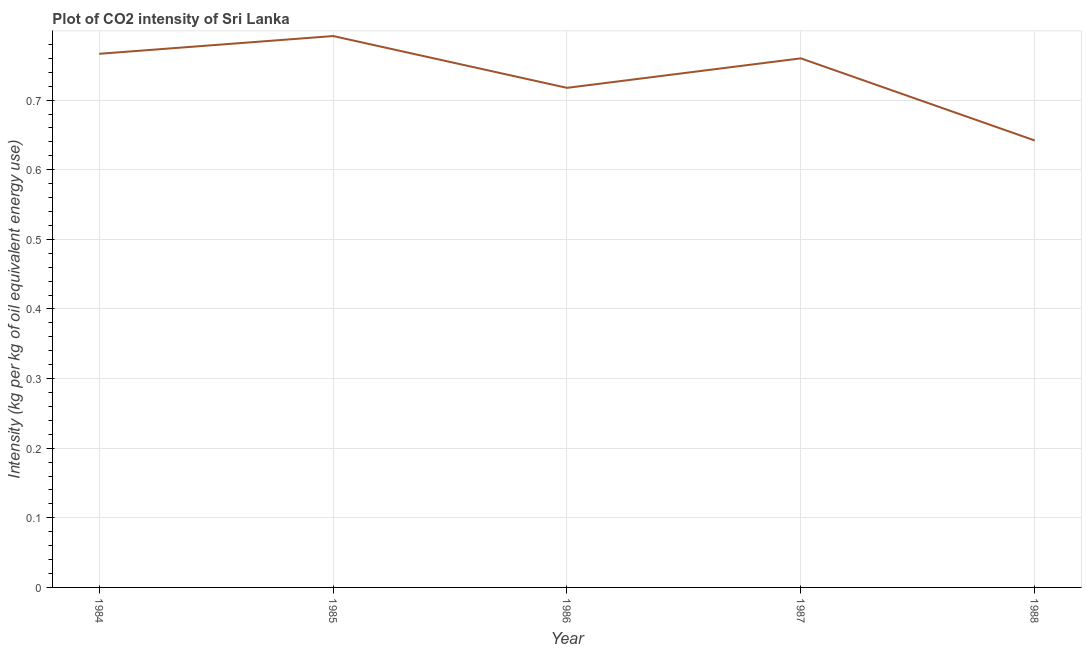What is the co2 intensity in 1988?
Your answer should be compact. 0.64. Across all years, what is the maximum co2 intensity?
Make the answer very short. 0.79. Across all years, what is the minimum co2 intensity?
Your answer should be very brief. 0.64. In which year was the co2 intensity maximum?
Offer a very short reply. 1985. What is the sum of the co2 intensity?
Offer a terse response. 3.68. What is the difference between the co2 intensity in 1985 and 1986?
Your answer should be compact. 0.07. What is the average co2 intensity per year?
Provide a succinct answer. 0.74. What is the median co2 intensity?
Make the answer very short. 0.76. In how many years, is the co2 intensity greater than 0.30000000000000004 kg?
Keep it short and to the point. 5. Do a majority of the years between 1986 and 1985 (inclusive) have co2 intensity greater than 0.6600000000000001 kg?
Ensure brevity in your answer.  No. What is the ratio of the co2 intensity in 1985 to that in 1988?
Offer a terse response. 1.23. Is the co2 intensity in 1984 less than that in 1988?
Your answer should be very brief. No. What is the difference between the highest and the second highest co2 intensity?
Your response must be concise. 0.03. Is the sum of the co2 intensity in 1986 and 1987 greater than the maximum co2 intensity across all years?
Offer a very short reply. Yes. What is the difference between the highest and the lowest co2 intensity?
Offer a terse response. 0.15. Does the co2 intensity monotonically increase over the years?
Your response must be concise. No. How many lines are there?
Provide a succinct answer. 1. What is the difference between two consecutive major ticks on the Y-axis?
Your answer should be compact. 0.1. Are the values on the major ticks of Y-axis written in scientific E-notation?
Your answer should be compact. No. What is the title of the graph?
Make the answer very short. Plot of CO2 intensity of Sri Lanka. What is the label or title of the X-axis?
Make the answer very short. Year. What is the label or title of the Y-axis?
Provide a short and direct response. Intensity (kg per kg of oil equivalent energy use). What is the Intensity (kg per kg of oil equivalent energy use) in 1984?
Your answer should be very brief. 0.77. What is the Intensity (kg per kg of oil equivalent energy use) in 1985?
Provide a short and direct response. 0.79. What is the Intensity (kg per kg of oil equivalent energy use) in 1986?
Your answer should be compact. 0.72. What is the Intensity (kg per kg of oil equivalent energy use) of 1987?
Provide a short and direct response. 0.76. What is the Intensity (kg per kg of oil equivalent energy use) in 1988?
Offer a very short reply. 0.64. What is the difference between the Intensity (kg per kg of oil equivalent energy use) in 1984 and 1985?
Provide a succinct answer. -0.03. What is the difference between the Intensity (kg per kg of oil equivalent energy use) in 1984 and 1986?
Offer a very short reply. 0.05. What is the difference between the Intensity (kg per kg of oil equivalent energy use) in 1984 and 1987?
Offer a very short reply. 0.01. What is the difference between the Intensity (kg per kg of oil equivalent energy use) in 1984 and 1988?
Offer a terse response. 0.12. What is the difference between the Intensity (kg per kg of oil equivalent energy use) in 1985 and 1986?
Provide a succinct answer. 0.07. What is the difference between the Intensity (kg per kg of oil equivalent energy use) in 1985 and 1987?
Keep it short and to the point. 0.03. What is the difference between the Intensity (kg per kg of oil equivalent energy use) in 1985 and 1988?
Your response must be concise. 0.15. What is the difference between the Intensity (kg per kg of oil equivalent energy use) in 1986 and 1987?
Your response must be concise. -0.04. What is the difference between the Intensity (kg per kg of oil equivalent energy use) in 1986 and 1988?
Give a very brief answer. 0.08. What is the difference between the Intensity (kg per kg of oil equivalent energy use) in 1987 and 1988?
Offer a very short reply. 0.12. What is the ratio of the Intensity (kg per kg of oil equivalent energy use) in 1984 to that in 1986?
Your response must be concise. 1.07. What is the ratio of the Intensity (kg per kg of oil equivalent energy use) in 1984 to that in 1987?
Offer a terse response. 1.01. What is the ratio of the Intensity (kg per kg of oil equivalent energy use) in 1984 to that in 1988?
Make the answer very short. 1.19. What is the ratio of the Intensity (kg per kg of oil equivalent energy use) in 1985 to that in 1986?
Your answer should be compact. 1.1. What is the ratio of the Intensity (kg per kg of oil equivalent energy use) in 1985 to that in 1987?
Ensure brevity in your answer.  1.04. What is the ratio of the Intensity (kg per kg of oil equivalent energy use) in 1985 to that in 1988?
Provide a succinct answer. 1.23. What is the ratio of the Intensity (kg per kg of oil equivalent energy use) in 1986 to that in 1987?
Offer a very short reply. 0.94. What is the ratio of the Intensity (kg per kg of oil equivalent energy use) in 1986 to that in 1988?
Offer a very short reply. 1.12. What is the ratio of the Intensity (kg per kg of oil equivalent energy use) in 1987 to that in 1988?
Offer a very short reply. 1.18. 